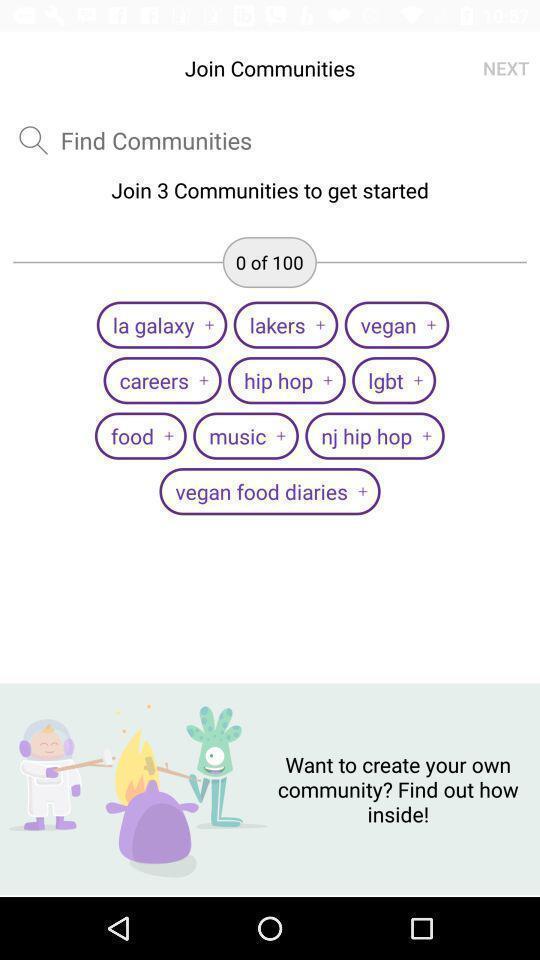Provide a description of this screenshot. Screen displaying the page to join communities. 